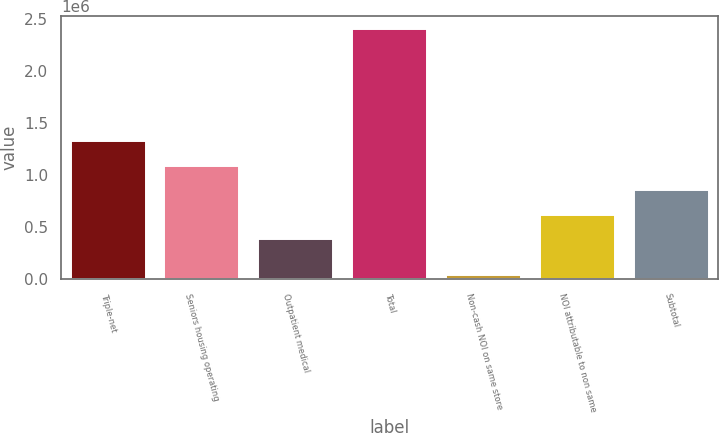<chart> <loc_0><loc_0><loc_500><loc_500><bar_chart><fcel>Triple-net<fcel>Seniors housing operating<fcel>Outpatient medical<fcel>Total<fcel>Non-cash NOI on same store<fcel>NOI attributable to non same<fcel>Subtotal<nl><fcel>1.326e+06<fcel>1.08957e+06<fcel>380264<fcel>2.40324e+06<fcel>38899<fcel>616698<fcel>853132<nl></chart> 